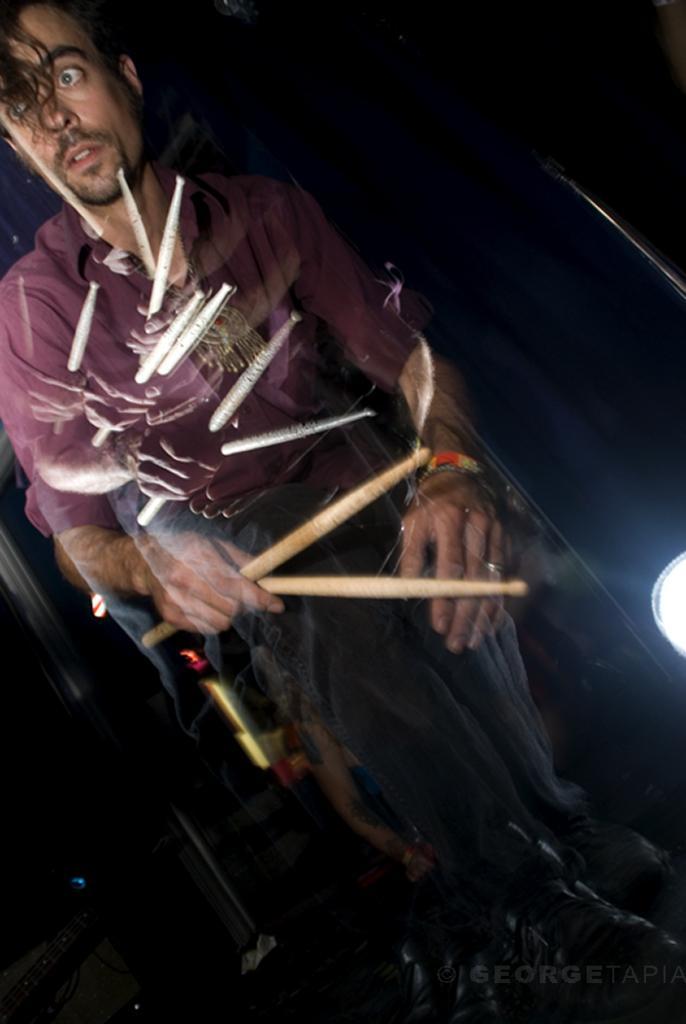Please provide a concise description of this image. In this picture we can see a man, he is holding sticks, beside to him we can find a light. 